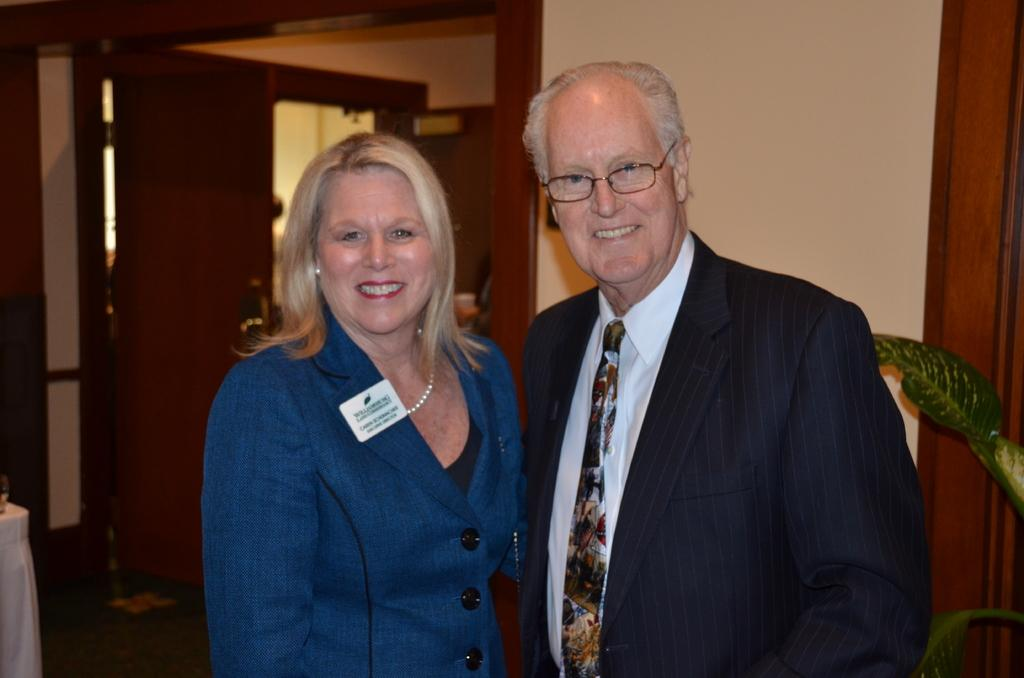Who is present in the image? There is a woman and an old man in the image. What is the woman doing in the image? The woman is laughing in the image. What is the woman wearing in the image? The woman is wearing a blue coat in the image. What is the old man wearing in the image? The old man is wearing a tie, shirt, and coat in the image. What can be seen on the right side of the image? There are leaves of a plant on the right side of the image. What is the level of pollution in the image? There is no information about pollution in the image, as it focuses on the woman and the old man. Is there a goat present in the image? No, there is no goat present in the image. 